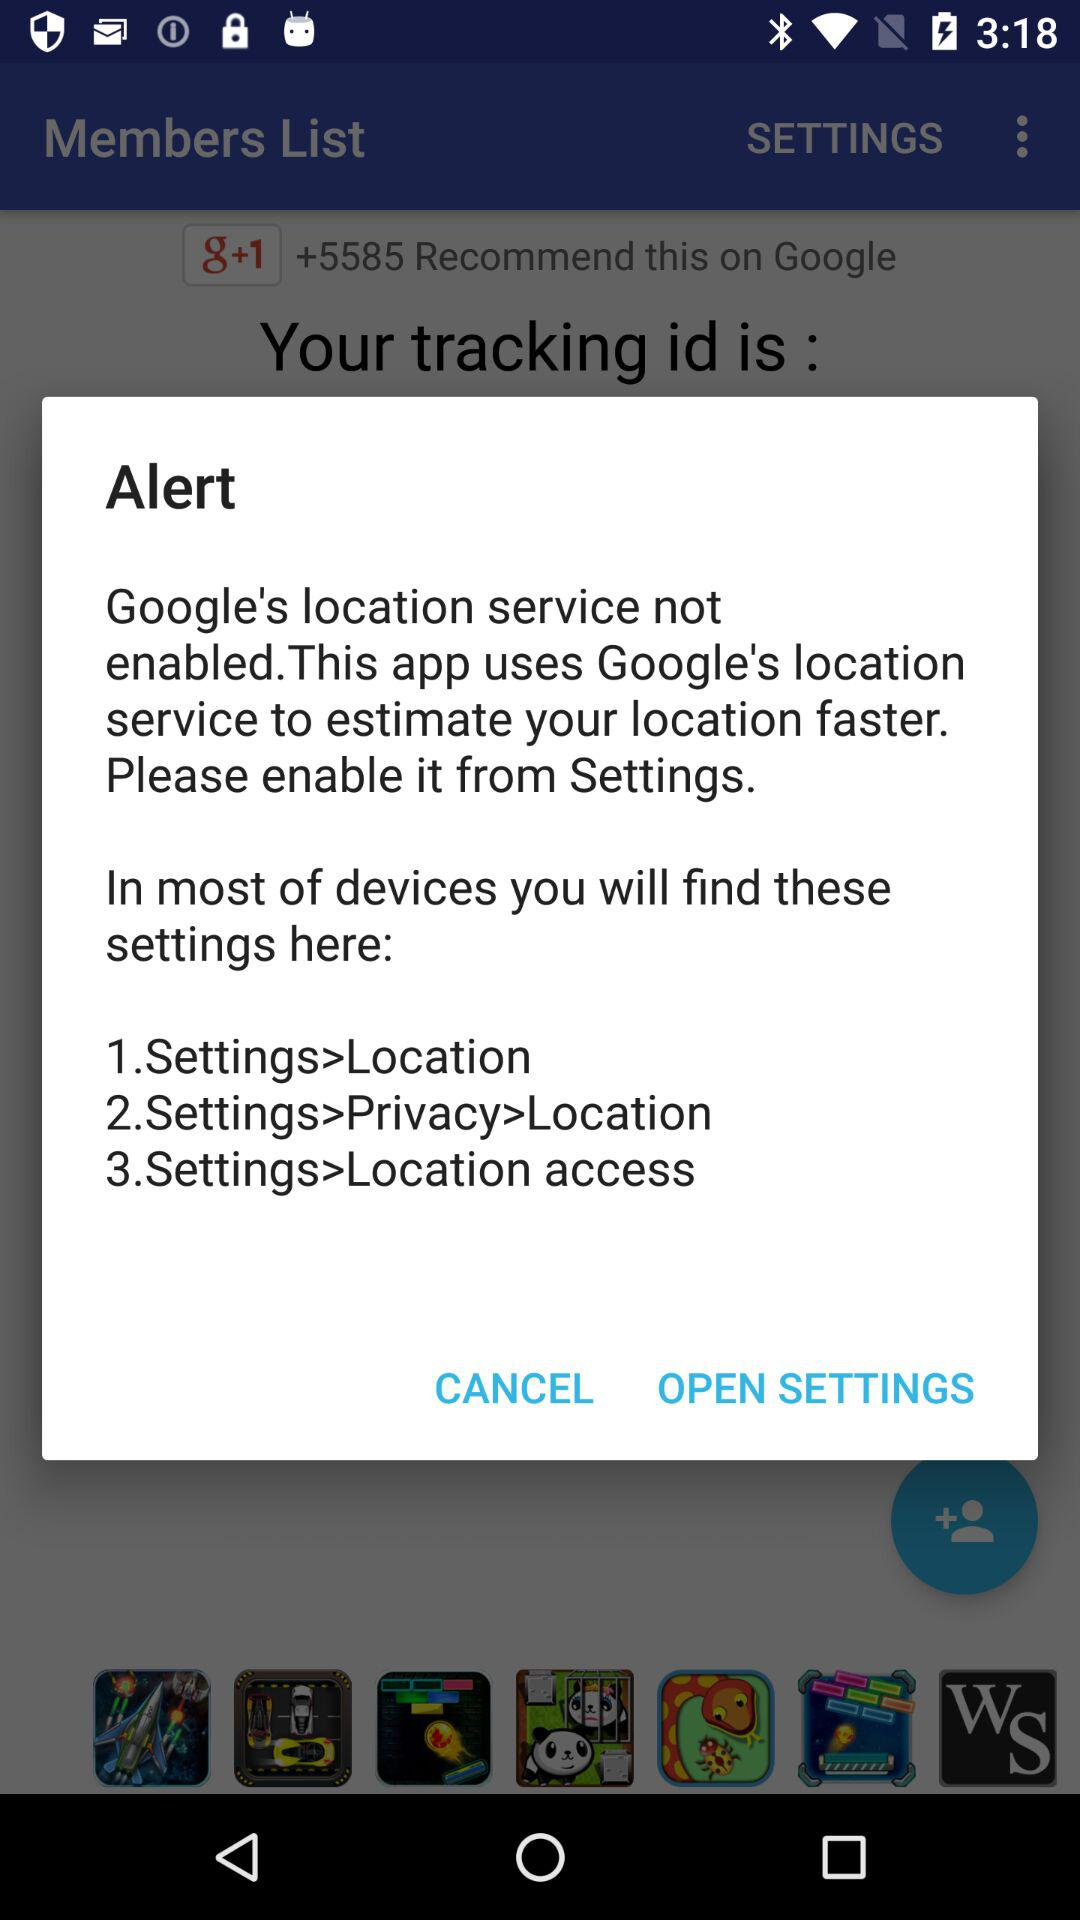What is the status of "Google's location service"? The status is "not enabled". 